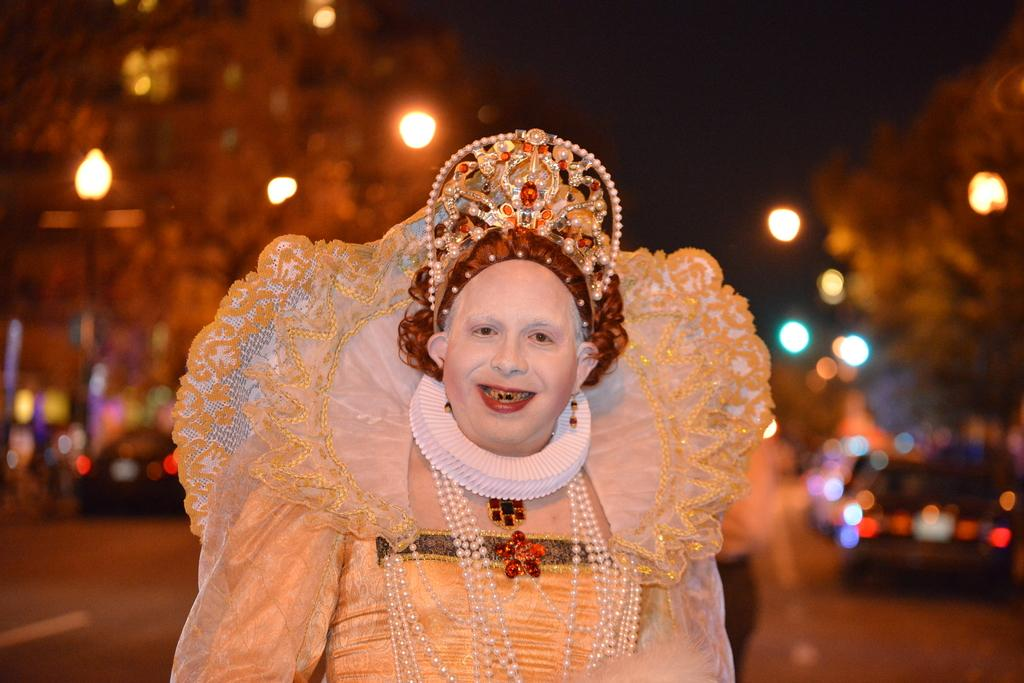What is the person in the image doing? The person is standing in the image and smiling. How is the person dressed in the image? The person is wearing a fancy dress and ornaments. What can be seen in the background of the image? There are trees, lights, and vehicles on the road in the background of the image. What type of basket is the person holding in the image? There is no basket present in the image; the person is not holding anything. 